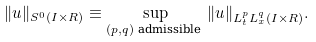Convert formula to latex. <formula><loc_0><loc_0><loc_500><loc_500>\| u \| _ { S ^ { 0 } ( I \times R ) } \equiv \sup _ { ( p , q ) \text { admissible } } \| u \| _ { L _ { t } ^ { p } L _ { x } ^ { q } ( I \times R ) } .</formula> 